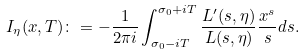Convert formula to latex. <formula><loc_0><loc_0><loc_500><loc_500>I _ { \eta } ( x , T ) \colon = - \frac { 1 } { 2 \pi i } \int _ { \sigma _ { 0 } - i T } ^ { \sigma _ { 0 } + i T } \frac { L ^ { \prime } ( s , \eta ) } { L ( s , \eta ) } \frac { x ^ { s } } { s } d s .</formula> 